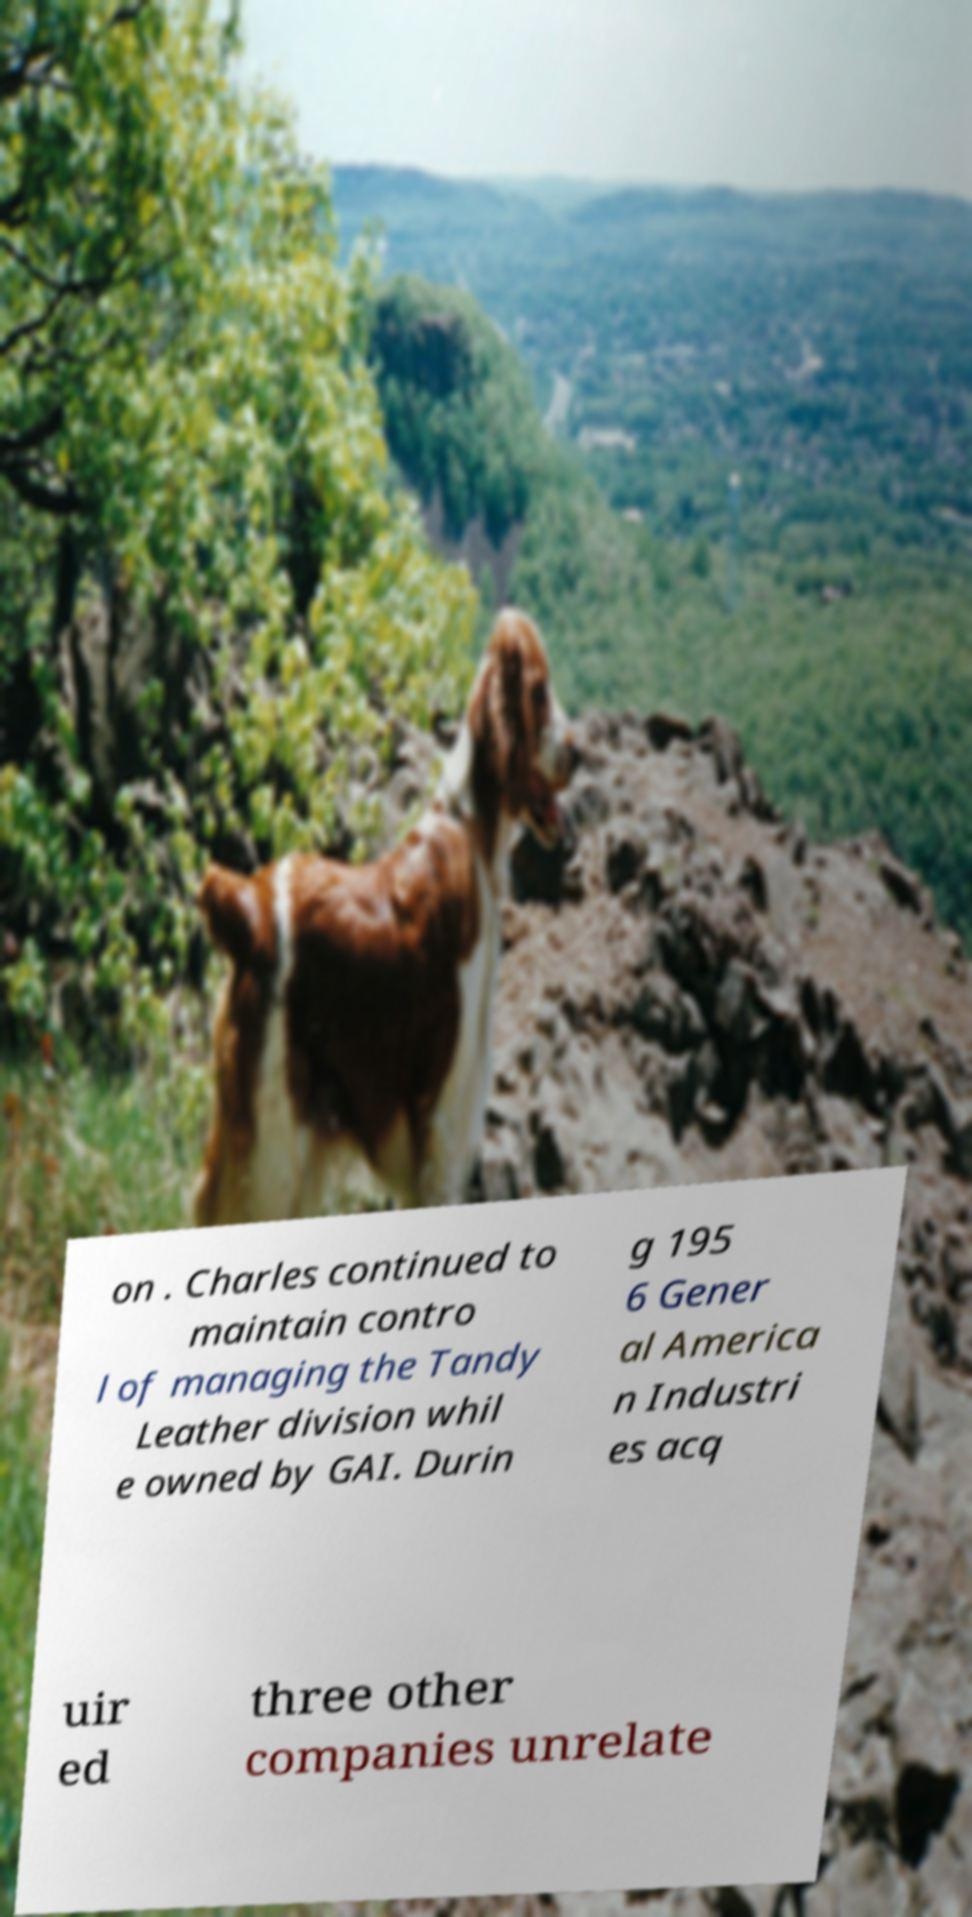Please identify and transcribe the text found in this image. on . Charles continued to maintain contro l of managing the Tandy Leather division whil e owned by GAI. Durin g 195 6 Gener al America n Industri es acq uir ed three other companies unrelate 